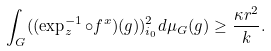Convert formula to latex. <formula><loc_0><loc_0><loc_500><loc_500>\int _ { G } ( ( \exp _ { z } ^ { - 1 } \circ f ^ { x } ) ( g ) ) _ { i _ { 0 } } ^ { 2 } d \mu _ { G } ( g ) \geq \frac { \kappa r ^ { 2 } } { k } .</formula> 